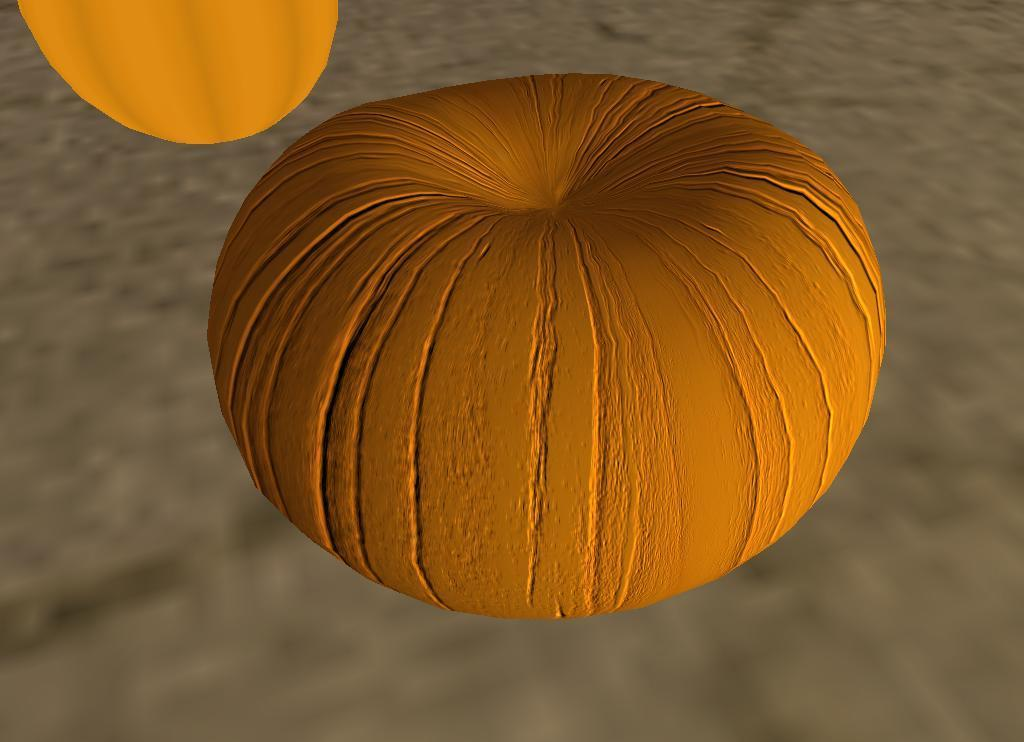What can be observed about the image's appearance? The image is edited. What is the main subject in the center of the image? There is a pumpkin in the center of the image. Reasoning: Let' Let's think step by step in order to produce the conversation. We start by acknowledging the fact that the image is edited, which may affect the overall appearance and context. Then, we focus on the main subject of the image, which is the pumpkin, and describe its location and characteristics. Absurd Question/Answer: What type of advice is being given in the image? There is no advice present in the image; it features a pumpkin in the center. What kind of vessel is being used to hold the pumpkin in the image? There is no vessel holding the pumpkin in the image; it is simply placed in the center. 